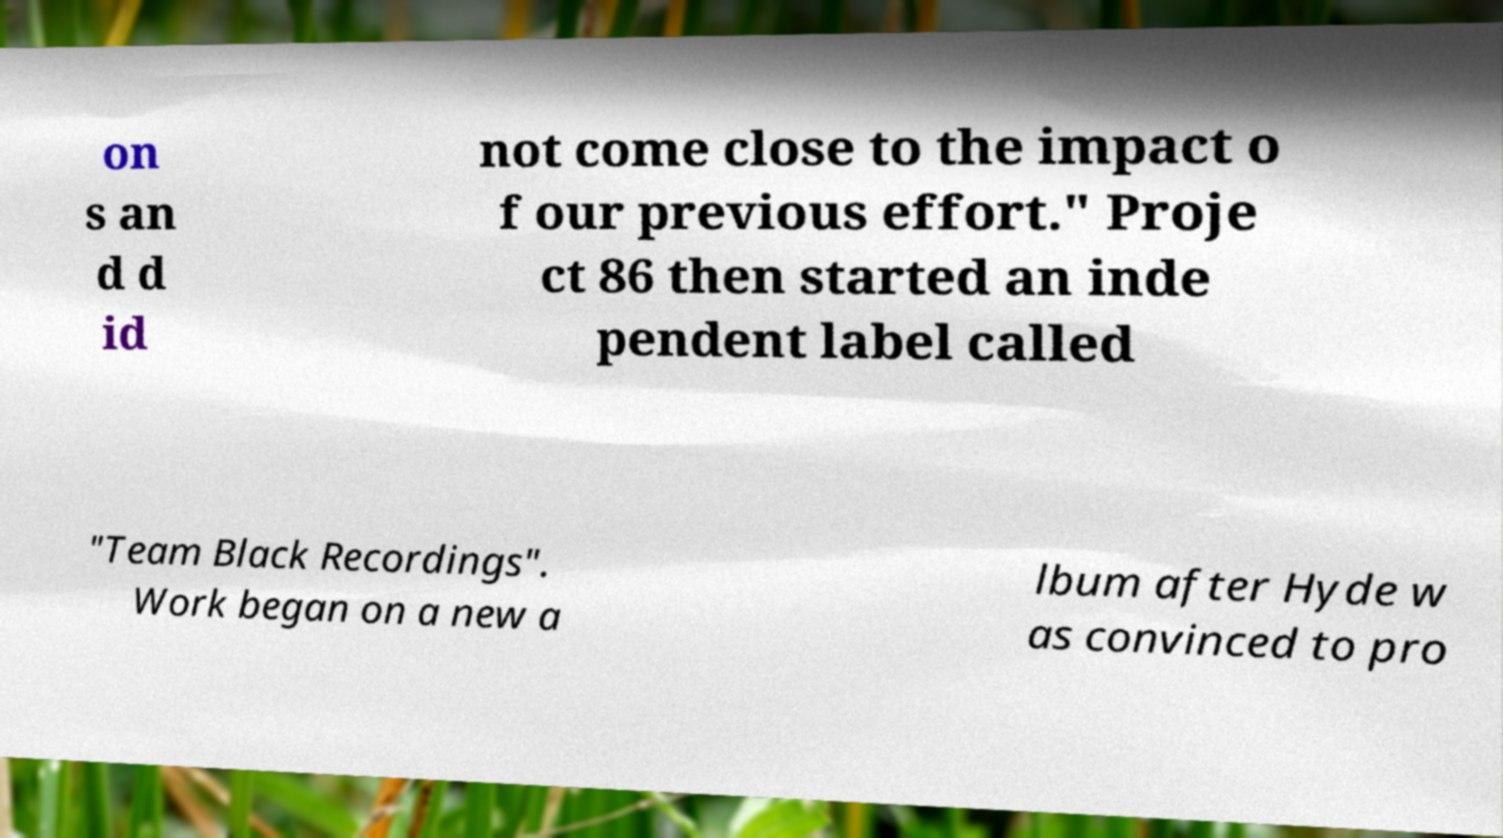For documentation purposes, I need the text within this image transcribed. Could you provide that? on s an d d id not come close to the impact o f our previous effort." Proje ct 86 then started an inde pendent label called "Team Black Recordings". Work began on a new a lbum after Hyde w as convinced to pro 